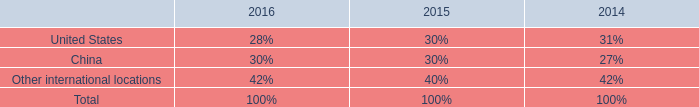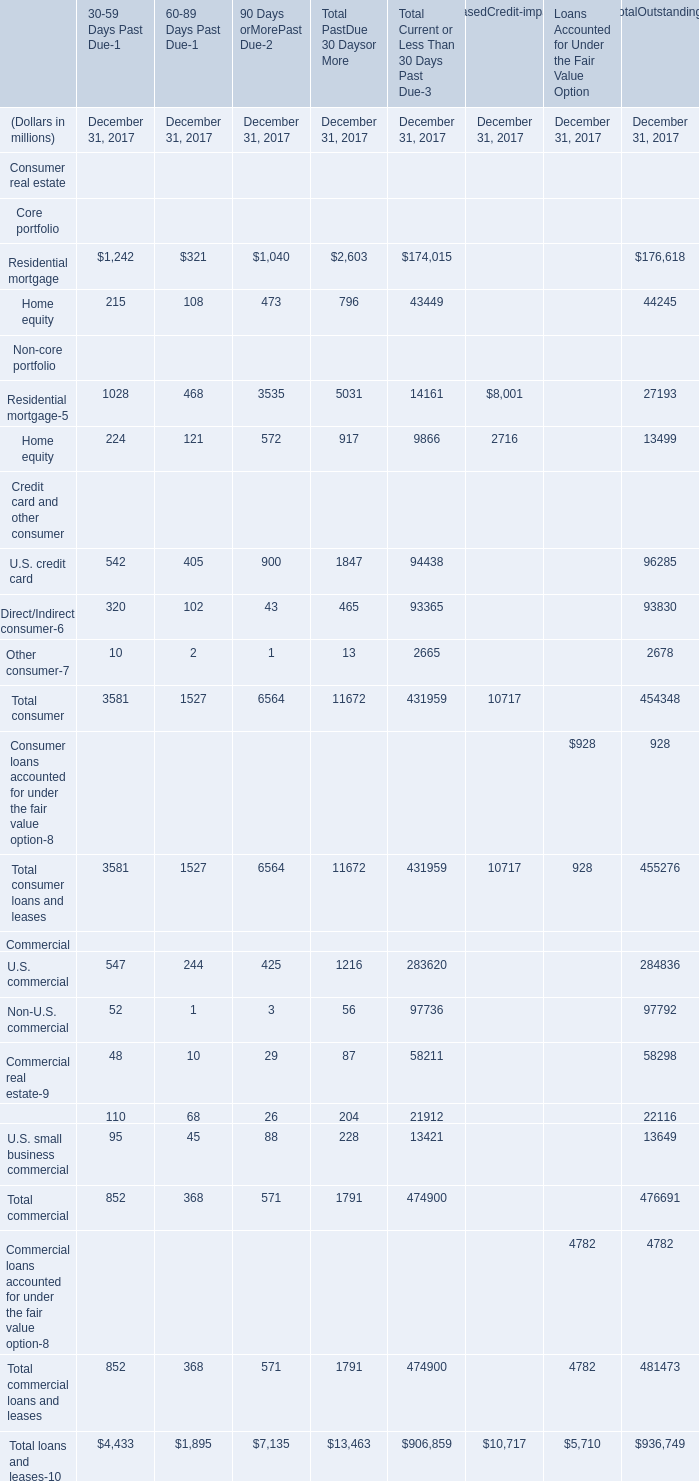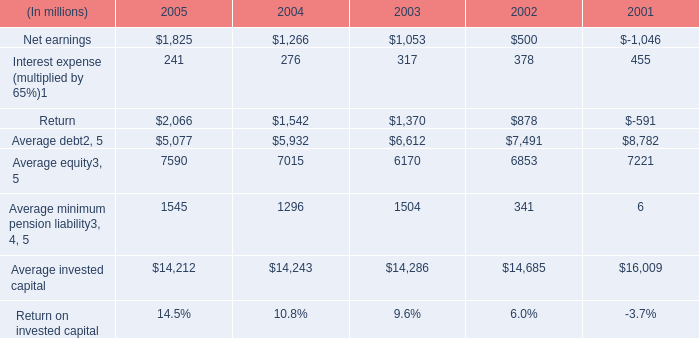what's the total amount of Average invested capital of 2003, Residential mortgage of 90 Days orMorePast Due December 31, 2017, and Total commercial Commercial of Total Current or Less Than 30 Days Past Due December 31, 2017 ? 
Computations: ((14286.0 + 1040.0) + 474900.0)
Answer: 490226.0. 